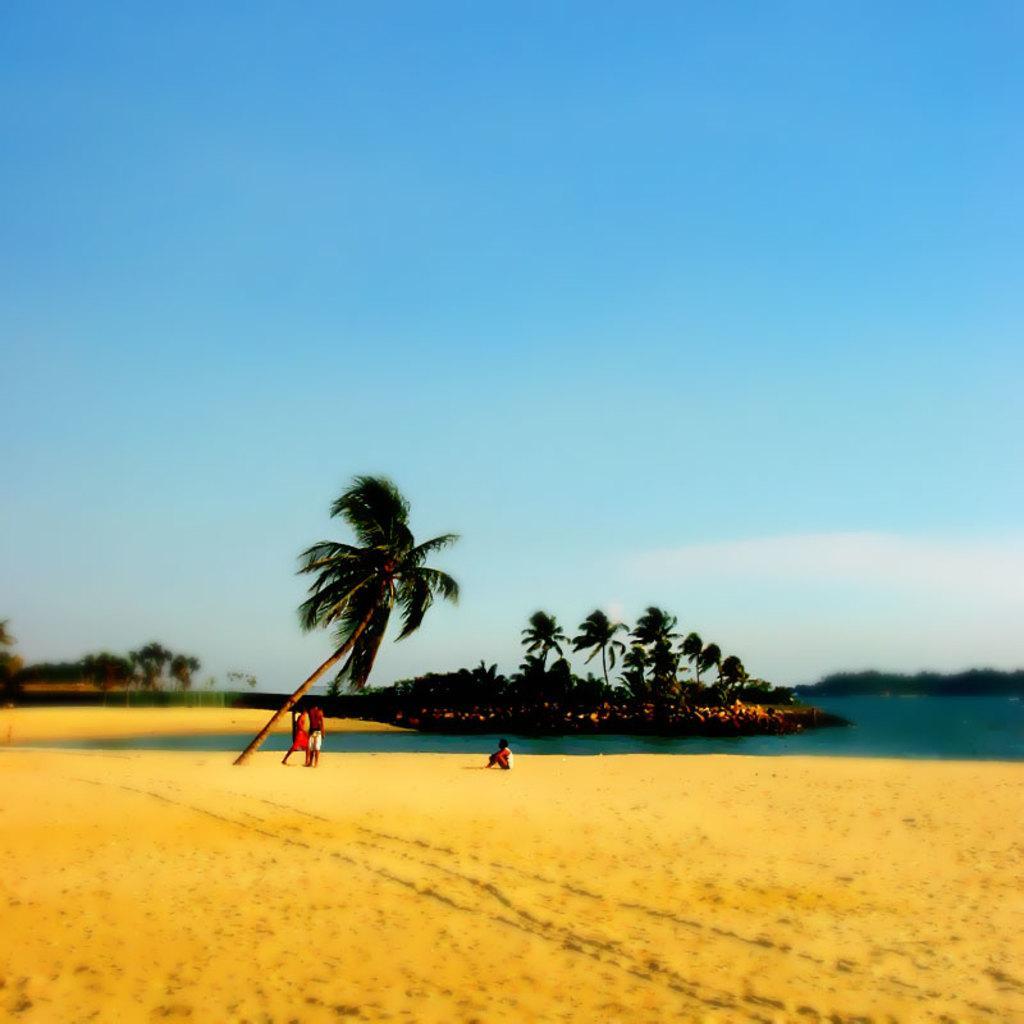Please provide a concise description of this image. In this picture there are two persons who are standing near to this coconut tree, besides them we can see another person who is sitting on the sand. On the background we can see many trees. On the right we can see river. On the top we can see sky and clouds. 